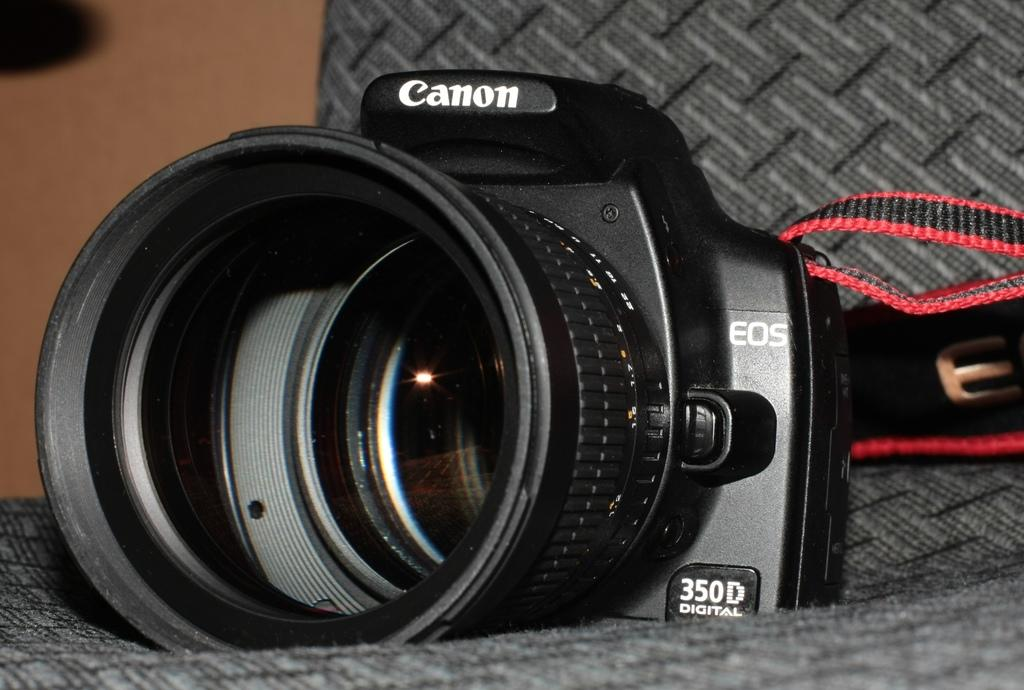What type of object is the main subject in the image? There is a black color camera in the image. Can you describe the camera in the image? The camera is black in color. What type of thrill can be seen in the image? There is no thrill present in the image; it features a black color camera. What design elements are present in the camera in the image? The provided facts do not mention any specific design elements of the camera. 